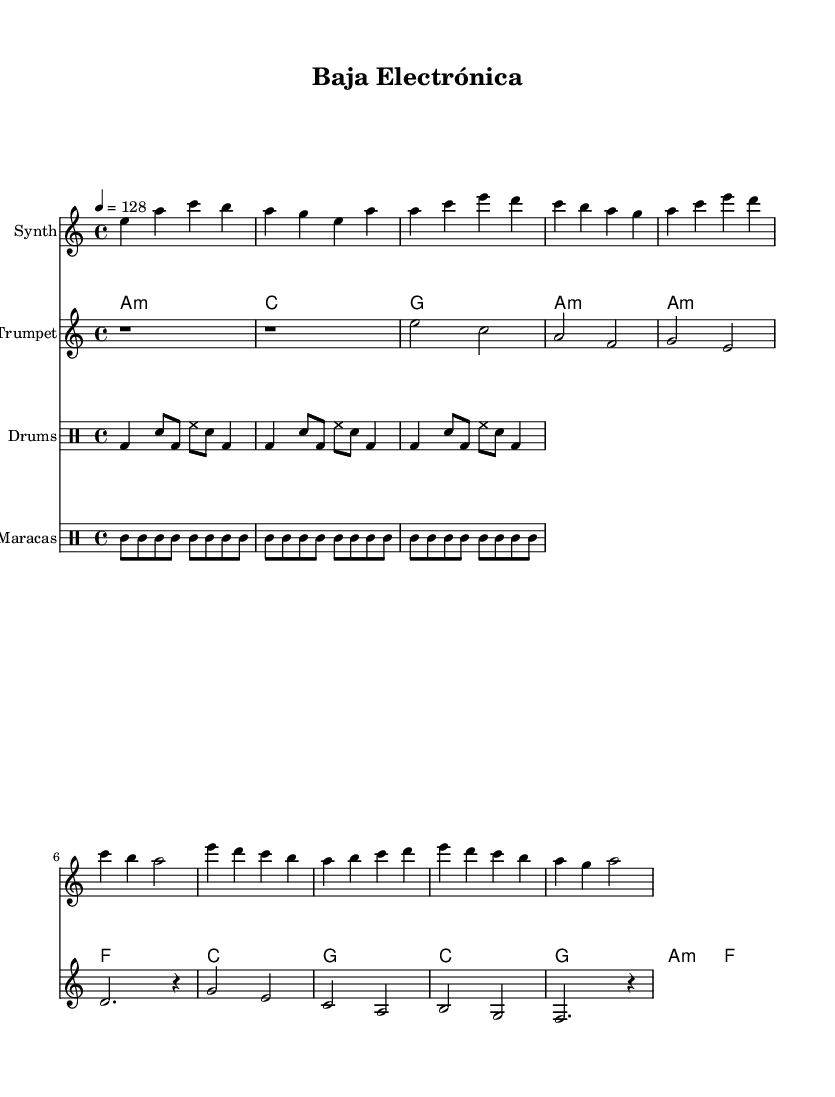What is the key signature of this music? The key signature is A minor, which contains no sharps and has one flat. A minor is the relative minor of C major, which also has no sharps or flats.
Answer: A minor What is the time signature of this music? The time signature is indicated as 4/4, meaning there are four beats in each measure and a quarter note receives one beat.
Answer: 4/4 What is the tempo marking for the piece? The tempo marking indicates a speed of 128 beats per minute (bpm), which suggests a lively tempo for an electronic piece.
Answer: 128 What instruments are arranged in the score? The score contains a synth, trumpet, drums, and maracas. Each instrument has a designated part, illustrating a blend of electronic and traditional sounds.
Answer: Synth, Trumpet, Drums, Maracas Which chord is used at the beginning of the verse? The first chord of the verse is A minor, established in the chord section. It provides the harmonic foundation for the melody that follows.
Answer: A minor How many measures are in the chorus section? The chorus section consists of four measures, as indicated by the structure of the musical notation for that part. This is a common format in many music genres.
Answer: 4 What is the primary rhythmic pattern used throughout the piece? The primary rhythmic pattern is maintained with a consistent drum pattern that features bass drum and snare repetitions, typical for electronic music, alongside maracas emphasizing the Latin rhythm.
Answer: Bass drum and snare pattern 